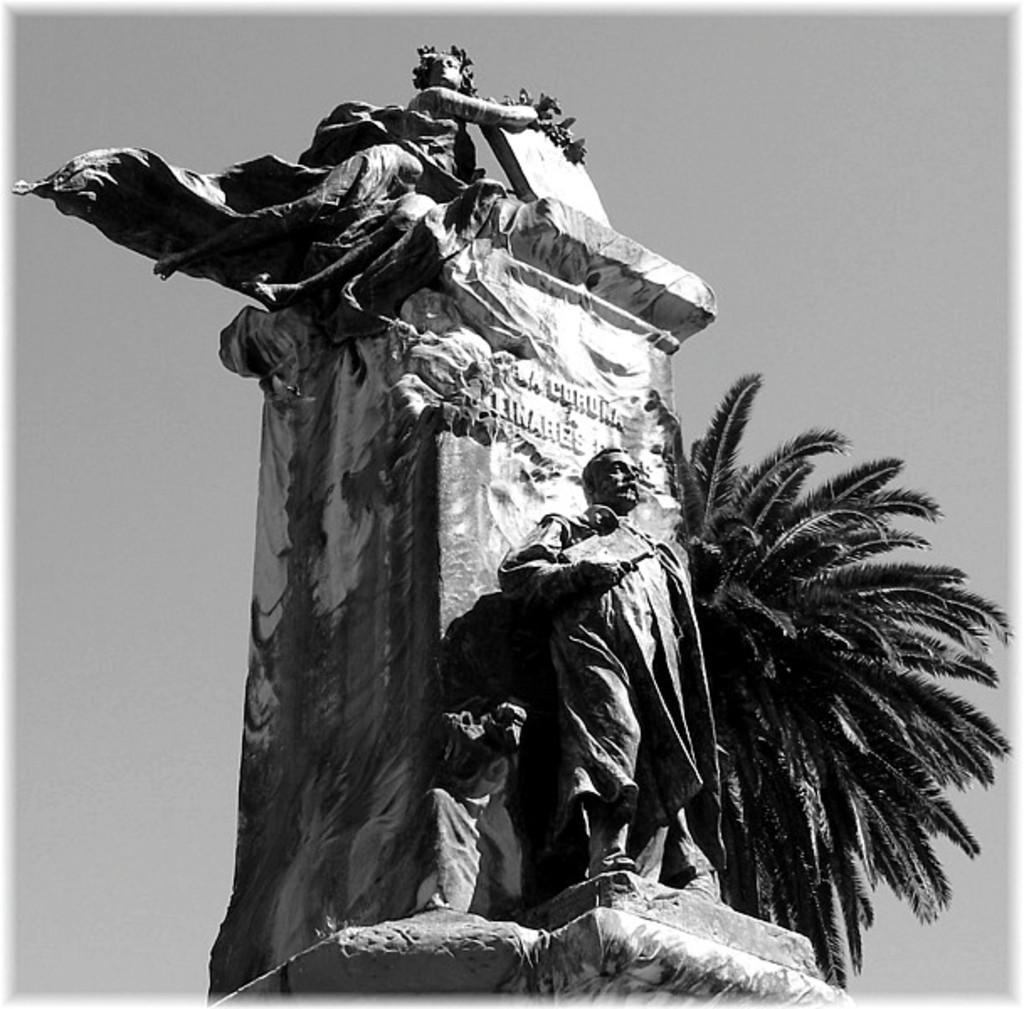How would you summarize this image in a sentence or two? This is a black and white image and here we can see a statue and a tree. In the background, there is sky. 